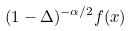Convert formula to latex. <formula><loc_0><loc_0><loc_500><loc_500>( 1 - \Delta ) ^ { - \alpha / 2 } f ( x )</formula> 